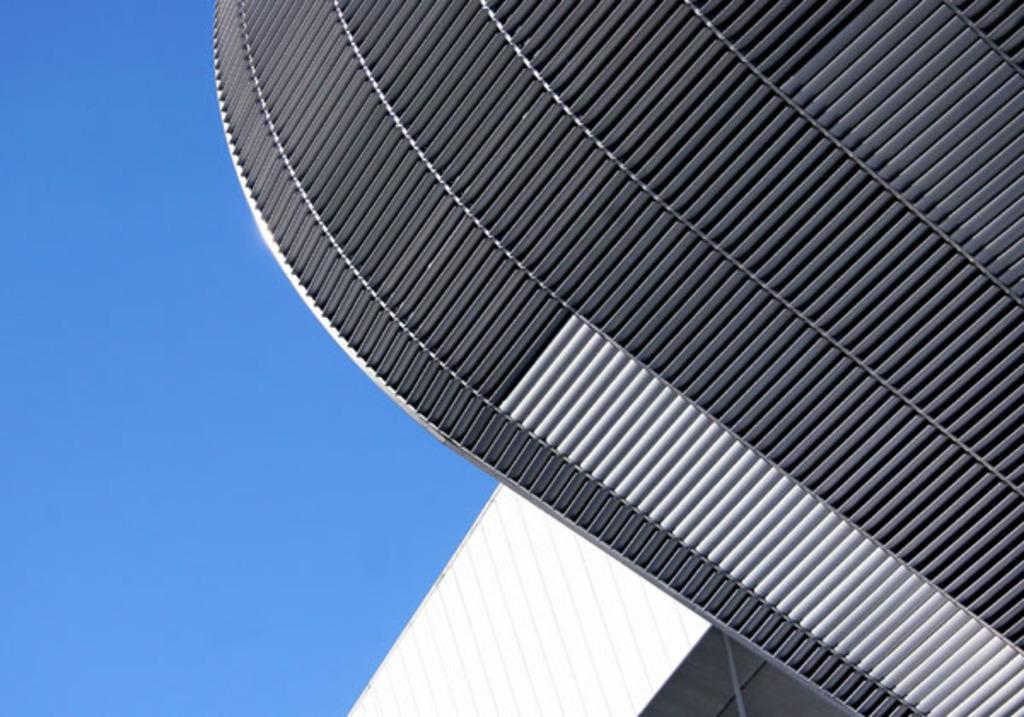What type of structure is depicted in the image? There is an architecture in the image. What can be seen in the background of the image? The sky is visible in the background of the image. What type of brush is used to paint the architecture in the image? There is no indication that the architecture in the image is a painting, so it is not possible to determine what type of brush was used. 